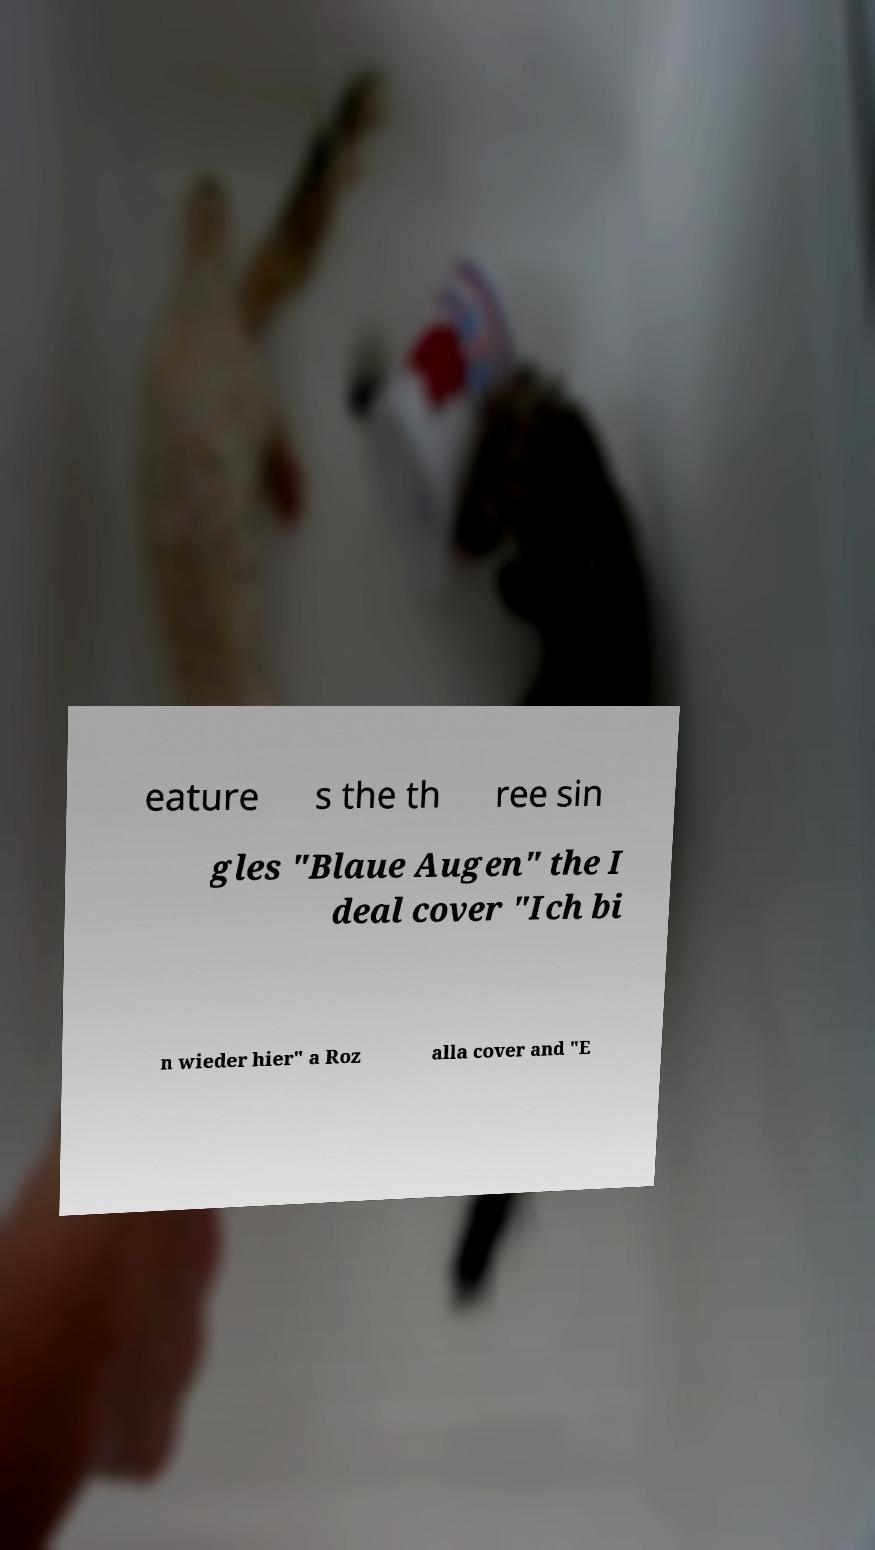What messages or text are displayed in this image? I need them in a readable, typed format. eature s the th ree sin gles "Blaue Augen" the I deal cover "Ich bi n wieder hier" a Roz alla cover and "E 